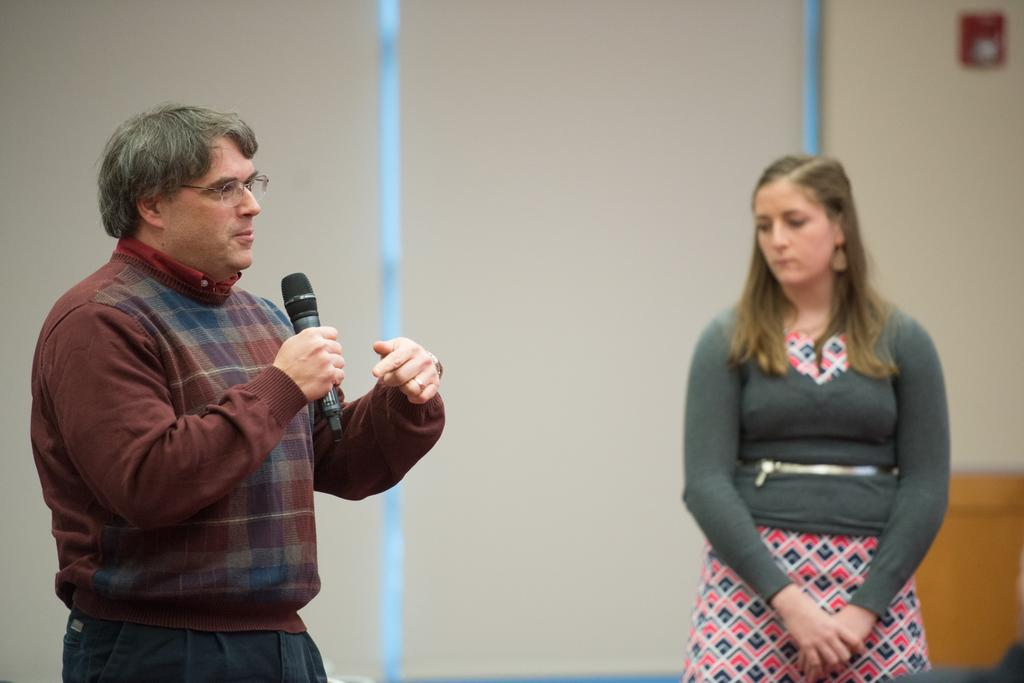What is the main subject of the image? The main subject of the image is a man. What is the man doing in the image? The man is standing and talking in the image. What object is the man holding in the image? The man is holding a microphone in the image. Can you describe the woman in the image? There is a woman in the image, but no specific details about her are provided. What can be seen in the background of the image? There is a wall in the background of the image. What time is displayed on the clock in the image? There is no clock present in the image. How many thumbs does the man have on his left hand in the image? The number of thumbs the man has on his left hand cannot be determined from the image, as it is not visible. 